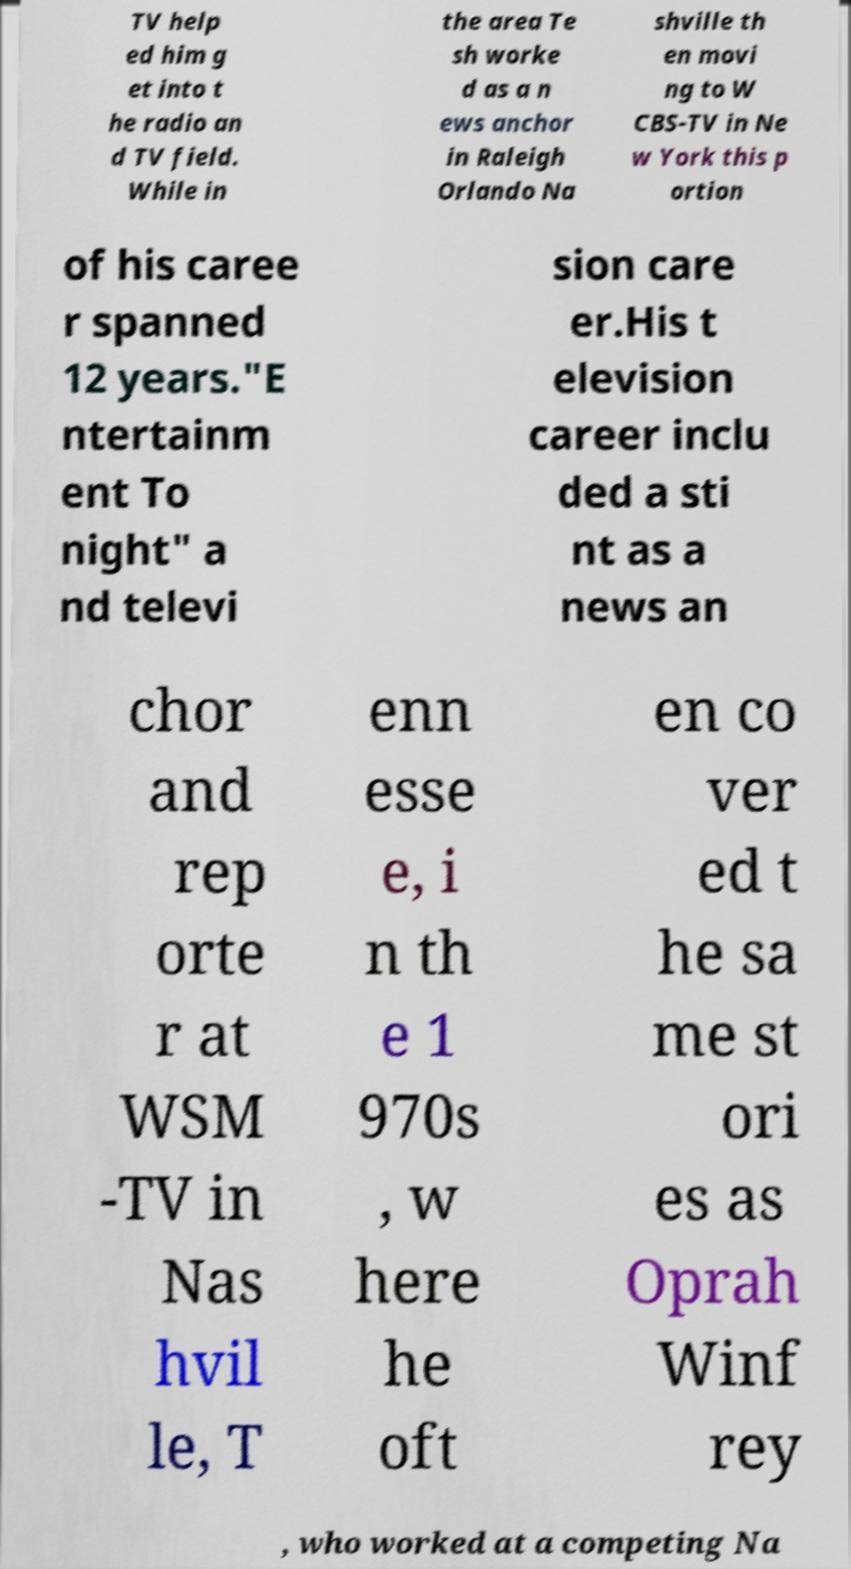What messages or text are displayed in this image? I need them in a readable, typed format. TV help ed him g et into t he radio an d TV field. While in the area Te sh worke d as a n ews anchor in Raleigh Orlando Na shville th en movi ng to W CBS-TV in Ne w York this p ortion of his caree r spanned 12 years."E ntertainm ent To night" a nd televi sion care er.His t elevision career inclu ded a sti nt as a news an chor and rep orte r at WSM -TV in Nas hvil le, T enn esse e, i n th e 1 970s , w here he oft en co ver ed t he sa me st ori es as Oprah Winf rey , who worked at a competing Na 